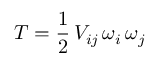<formula> <loc_0><loc_0><loc_500><loc_500>T = \frac { 1 } { 2 } \, V _ { i j } \, \omega _ { i } \, \omega _ { j }</formula> 